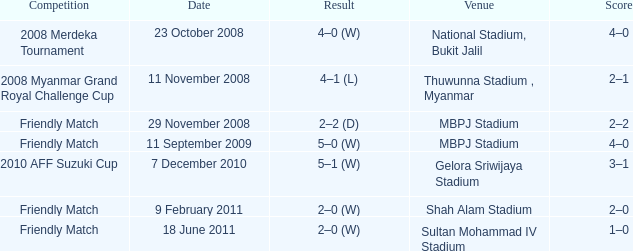Give me the full table as a dictionary. {'header': ['Competition', 'Date', 'Result', 'Venue', 'Score'], 'rows': [['2008 Merdeka Tournament', '23 October 2008', '4–0 (W)', 'National Stadium, Bukit Jalil', '4–0'], ['2008 Myanmar Grand Royal Challenge Cup', '11 November 2008', '4–1 (L)', 'Thuwunna Stadium , Myanmar', '2–1'], ['Friendly Match', '29 November 2008', '2–2 (D)', 'MBPJ Stadium', '2–2'], ['Friendly Match', '11 September 2009', '5–0 (W)', 'MBPJ Stadium', '4–0'], ['2010 AFF Suzuki Cup', '7 December 2010', '5–1 (W)', 'Gelora Sriwijaya Stadium', '3–1'], ['Friendly Match', '9 February 2011', '2–0 (W)', 'Shah Alam Stadium', '2–0'], ['Friendly Match', '18 June 2011', '2–0 (W)', 'Sultan Mohammad IV Stadium', '1–0']]} What is the Result of the Competition at MBPJ Stadium with a Score of 4–0? 5–0 (W). 